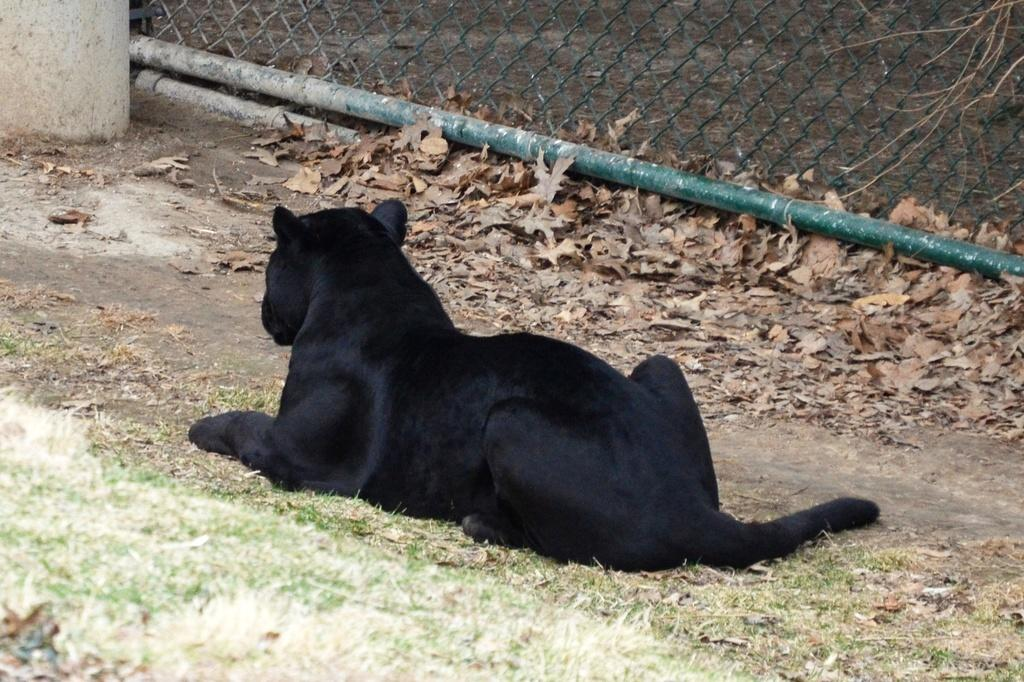What is the main subject in the center of the image? There is an animal in the center of the image. What type of vegetation is visible at the bottom of the image? There is grass at the bottom of the image. What can be seen in the background of the image? There is a fence and dry leaves in the background of the image. What type of worm is participating in the competition in the image? There is no worm or competition present in the image. 